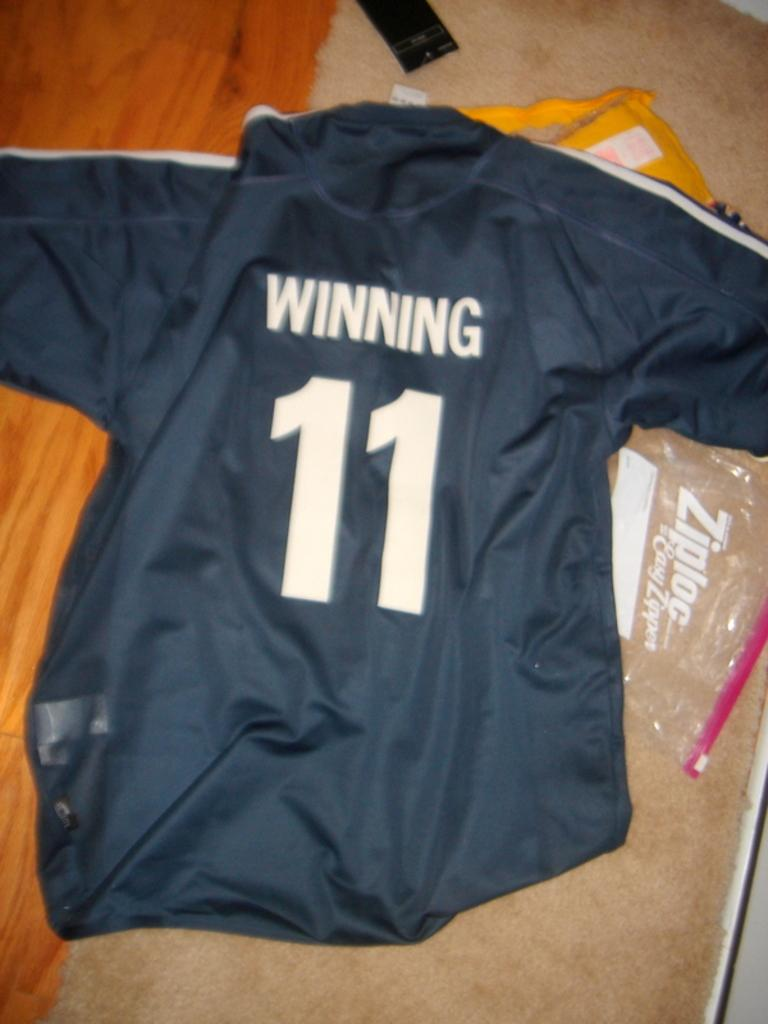Provide a one-sentence caption for the provided image. A blue jersey that says winning and has the number 11 on it. 